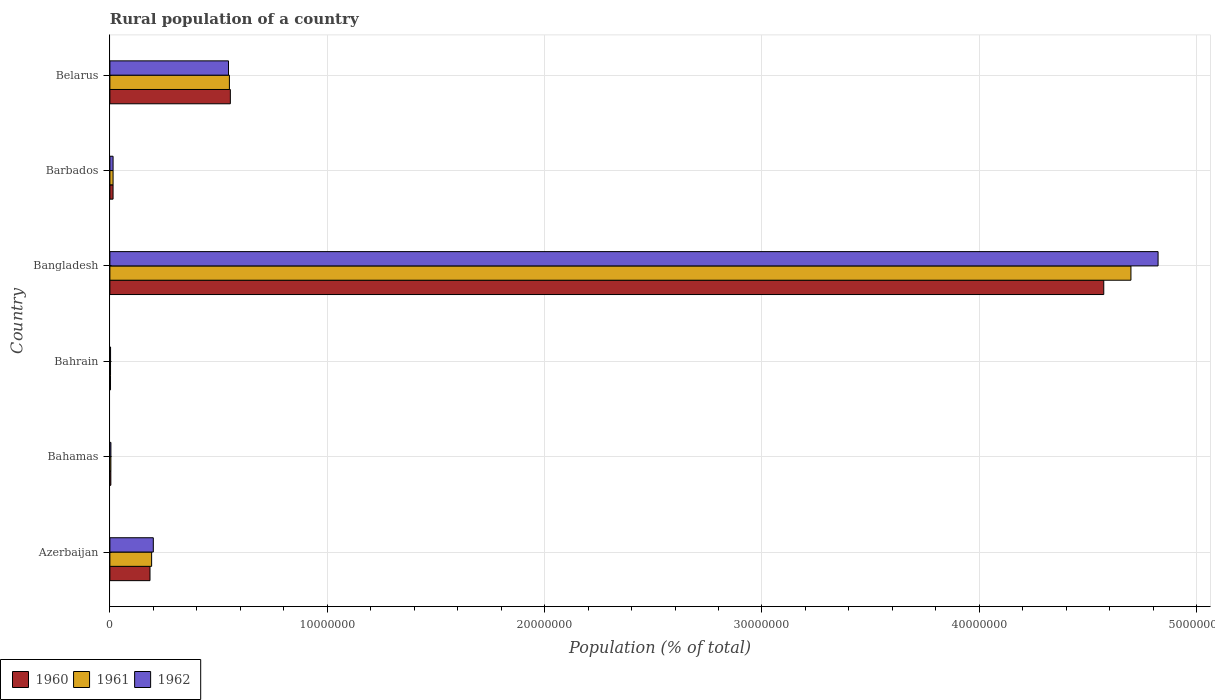How many different coloured bars are there?
Provide a short and direct response. 3. How many bars are there on the 6th tick from the top?
Offer a very short reply. 3. What is the label of the 2nd group of bars from the top?
Your answer should be compact. Barbados. In how many cases, is the number of bars for a given country not equal to the number of legend labels?
Provide a short and direct response. 0. What is the rural population in 1960 in Bangladesh?
Your response must be concise. 4.57e+07. Across all countries, what is the maximum rural population in 1962?
Keep it short and to the point. 4.82e+07. Across all countries, what is the minimum rural population in 1960?
Give a very brief answer. 2.87e+04. In which country was the rural population in 1960 minimum?
Provide a short and direct response. Bahrain. What is the total rural population in 1962 in the graph?
Offer a very short reply. 5.59e+07. What is the difference between the rural population in 1960 in Barbados and that in Belarus?
Ensure brevity in your answer.  -5.40e+06. What is the difference between the rural population in 1962 in Bahamas and the rural population in 1960 in Barbados?
Offer a very short reply. -9.90e+04. What is the average rural population in 1960 per country?
Provide a succinct answer. 8.89e+06. What is the difference between the rural population in 1962 and rural population in 1960 in Bahamas?
Your answer should be compact. 2863. In how many countries, is the rural population in 1962 greater than 14000000 %?
Provide a succinct answer. 1. What is the ratio of the rural population in 1960 in Azerbaijan to that in Bahrain?
Offer a terse response. 64.22. Is the rural population in 1962 in Azerbaijan less than that in Barbados?
Provide a succinct answer. No. Is the difference between the rural population in 1962 in Bahamas and Belarus greater than the difference between the rural population in 1960 in Bahamas and Belarus?
Ensure brevity in your answer.  Yes. What is the difference between the highest and the second highest rural population in 1960?
Your response must be concise. 4.02e+07. What is the difference between the highest and the lowest rural population in 1962?
Offer a very short reply. 4.82e+07. Is the sum of the rural population in 1960 in Bahrain and Bangladesh greater than the maximum rural population in 1962 across all countries?
Your answer should be compact. No. What does the 3rd bar from the bottom in Bangladesh represents?
Your answer should be compact. 1962. How many bars are there?
Make the answer very short. 18. What is the difference between two consecutive major ticks on the X-axis?
Your answer should be very brief. 1.00e+07. Are the values on the major ticks of X-axis written in scientific E-notation?
Provide a succinct answer. No. Does the graph contain grids?
Offer a terse response. Yes. How many legend labels are there?
Your answer should be very brief. 3. What is the title of the graph?
Provide a succinct answer. Rural population of a country. Does "1977" appear as one of the legend labels in the graph?
Your answer should be very brief. No. What is the label or title of the X-axis?
Make the answer very short. Population (% of total). What is the label or title of the Y-axis?
Offer a very short reply. Country. What is the Population (% of total) in 1960 in Azerbaijan?
Offer a terse response. 1.85e+06. What is the Population (% of total) in 1961 in Azerbaijan?
Your response must be concise. 1.92e+06. What is the Population (% of total) in 1962 in Azerbaijan?
Make the answer very short. 2.00e+06. What is the Population (% of total) in 1960 in Bahamas?
Ensure brevity in your answer.  4.41e+04. What is the Population (% of total) of 1961 in Bahamas?
Your answer should be compact. 4.55e+04. What is the Population (% of total) in 1962 in Bahamas?
Provide a short and direct response. 4.70e+04. What is the Population (% of total) of 1960 in Bahrain?
Your response must be concise. 2.87e+04. What is the Population (% of total) in 1961 in Bahrain?
Give a very brief answer. 2.97e+04. What is the Population (% of total) in 1962 in Bahrain?
Offer a terse response. 3.05e+04. What is the Population (% of total) in 1960 in Bangladesh?
Give a very brief answer. 4.57e+07. What is the Population (% of total) in 1961 in Bangladesh?
Provide a short and direct response. 4.70e+07. What is the Population (% of total) of 1962 in Bangladesh?
Give a very brief answer. 4.82e+07. What is the Population (% of total) of 1960 in Barbados?
Give a very brief answer. 1.46e+05. What is the Population (% of total) in 1961 in Barbados?
Keep it short and to the point. 1.46e+05. What is the Population (% of total) of 1962 in Barbados?
Make the answer very short. 1.47e+05. What is the Population (% of total) in 1960 in Belarus?
Your response must be concise. 5.54e+06. What is the Population (% of total) in 1961 in Belarus?
Your answer should be very brief. 5.50e+06. What is the Population (% of total) in 1962 in Belarus?
Make the answer very short. 5.46e+06. Across all countries, what is the maximum Population (% of total) in 1960?
Give a very brief answer. 4.57e+07. Across all countries, what is the maximum Population (% of total) in 1961?
Offer a very short reply. 4.70e+07. Across all countries, what is the maximum Population (% of total) of 1962?
Your answer should be compact. 4.82e+07. Across all countries, what is the minimum Population (% of total) of 1960?
Offer a terse response. 2.87e+04. Across all countries, what is the minimum Population (% of total) of 1961?
Provide a short and direct response. 2.97e+04. Across all countries, what is the minimum Population (% of total) in 1962?
Give a very brief answer. 3.05e+04. What is the total Population (% of total) of 1960 in the graph?
Your answer should be very brief. 5.33e+07. What is the total Population (% of total) of 1961 in the graph?
Your answer should be very brief. 5.46e+07. What is the total Population (% of total) in 1962 in the graph?
Your response must be concise. 5.59e+07. What is the difference between the Population (% of total) of 1960 in Azerbaijan and that in Bahamas?
Make the answer very short. 1.80e+06. What is the difference between the Population (% of total) of 1961 in Azerbaijan and that in Bahamas?
Offer a terse response. 1.87e+06. What is the difference between the Population (% of total) in 1962 in Azerbaijan and that in Bahamas?
Offer a terse response. 1.95e+06. What is the difference between the Population (% of total) of 1960 in Azerbaijan and that in Bahrain?
Your response must be concise. 1.82e+06. What is the difference between the Population (% of total) in 1961 in Azerbaijan and that in Bahrain?
Keep it short and to the point. 1.89e+06. What is the difference between the Population (% of total) of 1962 in Azerbaijan and that in Bahrain?
Ensure brevity in your answer.  1.97e+06. What is the difference between the Population (% of total) in 1960 in Azerbaijan and that in Bangladesh?
Your answer should be very brief. -4.39e+07. What is the difference between the Population (% of total) in 1961 in Azerbaijan and that in Bangladesh?
Offer a very short reply. -4.51e+07. What is the difference between the Population (% of total) of 1962 in Azerbaijan and that in Bangladesh?
Offer a very short reply. -4.62e+07. What is the difference between the Population (% of total) of 1960 in Azerbaijan and that in Barbados?
Your answer should be compact. 1.70e+06. What is the difference between the Population (% of total) in 1961 in Azerbaijan and that in Barbados?
Your response must be concise. 1.77e+06. What is the difference between the Population (% of total) of 1962 in Azerbaijan and that in Barbados?
Your answer should be compact. 1.85e+06. What is the difference between the Population (% of total) in 1960 in Azerbaijan and that in Belarus?
Keep it short and to the point. -3.70e+06. What is the difference between the Population (% of total) in 1961 in Azerbaijan and that in Belarus?
Keep it short and to the point. -3.58e+06. What is the difference between the Population (% of total) of 1962 in Azerbaijan and that in Belarus?
Provide a short and direct response. -3.46e+06. What is the difference between the Population (% of total) of 1960 in Bahamas and that in Bahrain?
Make the answer very short. 1.54e+04. What is the difference between the Population (% of total) in 1961 in Bahamas and that in Bahrain?
Make the answer very short. 1.59e+04. What is the difference between the Population (% of total) of 1962 in Bahamas and that in Bahrain?
Offer a very short reply. 1.64e+04. What is the difference between the Population (% of total) of 1960 in Bahamas and that in Bangladesh?
Ensure brevity in your answer.  -4.57e+07. What is the difference between the Population (% of total) in 1961 in Bahamas and that in Bangladesh?
Keep it short and to the point. -4.69e+07. What is the difference between the Population (% of total) in 1962 in Bahamas and that in Bangladesh?
Ensure brevity in your answer.  -4.82e+07. What is the difference between the Population (% of total) in 1960 in Bahamas and that in Barbados?
Give a very brief answer. -1.02e+05. What is the difference between the Population (% of total) in 1961 in Bahamas and that in Barbados?
Offer a very short reply. -1.01e+05. What is the difference between the Population (% of total) of 1962 in Bahamas and that in Barbados?
Ensure brevity in your answer.  -9.97e+04. What is the difference between the Population (% of total) of 1960 in Bahamas and that in Belarus?
Your response must be concise. -5.50e+06. What is the difference between the Population (% of total) in 1961 in Bahamas and that in Belarus?
Keep it short and to the point. -5.45e+06. What is the difference between the Population (% of total) in 1962 in Bahamas and that in Belarus?
Your answer should be very brief. -5.41e+06. What is the difference between the Population (% of total) in 1960 in Bahrain and that in Bangladesh?
Provide a succinct answer. -4.57e+07. What is the difference between the Population (% of total) of 1961 in Bahrain and that in Bangladesh?
Your response must be concise. -4.69e+07. What is the difference between the Population (% of total) in 1962 in Bahrain and that in Bangladesh?
Provide a succinct answer. -4.82e+07. What is the difference between the Population (% of total) in 1960 in Bahrain and that in Barbados?
Provide a short and direct response. -1.17e+05. What is the difference between the Population (% of total) of 1961 in Bahrain and that in Barbados?
Provide a succinct answer. -1.17e+05. What is the difference between the Population (% of total) of 1962 in Bahrain and that in Barbados?
Your answer should be compact. -1.16e+05. What is the difference between the Population (% of total) of 1960 in Bahrain and that in Belarus?
Keep it short and to the point. -5.51e+06. What is the difference between the Population (% of total) in 1961 in Bahrain and that in Belarus?
Your answer should be compact. -5.47e+06. What is the difference between the Population (% of total) in 1962 in Bahrain and that in Belarus?
Your answer should be very brief. -5.43e+06. What is the difference between the Population (% of total) in 1960 in Bangladesh and that in Barbados?
Give a very brief answer. 4.56e+07. What is the difference between the Population (% of total) in 1961 in Bangladesh and that in Barbados?
Make the answer very short. 4.68e+07. What is the difference between the Population (% of total) in 1962 in Bangladesh and that in Barbados?
Offer a very short reply. 4.81e+07. What is the difference between the Population (% of total) in 1960 in Bangladesh and that in Belarus?
Provide a succinct answer. 4.02e+07. What is the difference between the Population (% of total) in 1961 in Bangladesh and that in Belarus?
Your response must be concise. 4.15e+07. What is the difference between the Population (% of total) in 1962 in Bangladesh and that in Belarus?
Your response must be concise. 4.28e+07. What is the difference between the Population (% of total) in 1960 in Barbados and that in Belarus?
Your response must be concise. -5.40e+06. What is the difference between the Population (% of total) in 1961 in Barbados and that in Belarus?
Keep it short and to the point. -5.35e+06. What is the difference between the Population (% of total) of 1962 in Barbados and that in Belarus?
Keep it short and to the point. -5.31e+06. What is the difference between the Population (% of total) in 1960 in Azerbaijan and the Population (% of total) in 1961 in Bahamas?
Provide a short and direct response. 1.80e+06. What is the difference between the Population (% of total) in 1960 in Azerbaijan and the Population (% of total) in 1962 in Bahamas?
Your response must be concise. 1.80e+06. What is the difference between the Population (% of total) of 1961 in Azerbaijan and the Population (% of total) of 1962 in Bahamas?
Ensure brevity in your answer.  1.87e+06. What is the difference between the Population (% of total) in 1960 in Azerbaijan and the Population (% of total) in 1961 in Bahrain?
Offer a very short reply. 1.82e+06. What is the difference between the Population (% of total) of 1960 in Azerbaijan and the Population (% of total) of 1962 in Bahrain?
Keep it short and to the point. 1.81e+06. What is the difference between the Population (% of total) of 1961 in Azerbaijan and the Population (% of total) of 1962 in Bahrain?
Offer a very short reply. 1.89e+06. What is the difference between the Population (% of total) of 1960 in Azerbaijan and the Population (% of total) of 1961 in Bangladesh?
Your response must be concise. -4.51e+07. What is the difference between the Population (% of total) of 1960 in Azerbaijan and the Population (% of total) of 1962 in Bangladesh?
Your response must be concise. -4.64e+07. What is the difference between the Population (% of total) of 1961 in Azerbaijan and the Population (% of total) of 1962 in Bangladesh?
Your response must be concise. -4.63e+07. What is the difference between the Population (% of total) of 1960 in Azerbaijan and the Population (% of total) of 1961 in Barbados?
Provide a short and direct response. 1.70e+06. What is the difference between the Population (% of total) of 1960 in Azerbaijan and the Population (% of total) of 1962 in Barbados?
Provide a short and direct response. 1.70e+06. What is the difference between the Population (% of total) of 1961 in Azerbaijan and the Population (% of total) of 1962 in Barbados?
Ensure brevity in your answer.  1.77e+06. What is the difference between the Population (% of total) of 1960 in Azerbaijan and the Population (% of total) of 1961 in Belarus?
Your answer should be very brief. -3.65e+06. What is the difference between the Population (% of total) in 1960 in Azerbaijan and the Population (% of total) in 1962 in Belarus?
Your answer should be compact. -3.61e+06. What is the difference between the Population (% of total) of 1961 in Azerbaijan and the Population (% of total) of 1962 in Belarus?
Offer a very short reply. -3.54e+06. What is the difference between the Population (% of total) in 1960 in Bahamas and the Population (% of total) in 1961 in Bahrain?
Make the answer very short. 1.45e+04. What is the difference between the Population (% of total) of 1960 in Bahamas and the Population (% of total) of 1962 in Bahrain?
Provide a succinct answer. 1.36e+04. What is the difference between the Population (% of total) of 1961 in Bahamas and the Population (% of total) of 1962 in Bahrain?
Provide a short and direct response. 1.50e+04. What is the difference between the Population (% of total) of 1960 in Bahamas and the Population (% of total) of 1961 in Bangladesh?
Offer a very short reply. -4.69e+07. What is the difference between the Population (% of total) in 1960 in Bahamas and the Population (% of total) in 1962 in Bangladesh?
Your answer should be very brief. -4.82e+07. What is the difference between the Population (% of total) in 1961 in Bahamas and the Population (% of total) in 1962 in Bangladesh?
Make the answer very short. -4.82e+07. What is the difference between the Population (% of total) of 1960 in Bahamas and the Population (% of total) of 1961 in Barbados?
Provide a short and direct response. -1.02e+05. What is the difference between the Population (% of total) of 1960 in Bahamas and the Population (% of total) of 1962 in Barbados?
Ensure brevity in your answer.  -1.03e+05. What is the difference between the Population (% of total) in 1961 in Bahamas and the Population (% of total) in 1962 in Barbados?
Offer a terse response. -1.01e+05. What is the difference between the Population (% of total) of 1960 in Bahamas and the Population (% of total) of 1961 in Belarus?
Give a very brief answer. -5.45e+06. What is the difference between the Population (% of total) of 1960 in Bahamas and the Population (% of total) of 1962 in Belarus?
Your response must be concise. -5.41e+06. What is the difference between the Population (% of total) in 1961 in Bahamas and the Population (% of total) in 1962 in Belarus?
Ensure brevity in your answer.  -5.41e+06. What is the difference between the Population (% of total) of 1960 in Bahrain and the Population (% of total) of 1961 in Bangladesh?
Give a very brief answer. -4.69e+07. What is the difference between the Population (% of total) of 1960 in Bahrain and the Population (% of total) of 1962 in Bangladesh?
Make the answer very short. -4.82e+07. What is the difference between the Population (% of total) in 1961 in Bahrain and the Population (% of total) in 1962 in Bangladesh?
Ensure brevity in your answer.  -4.82e+07. What is the difference between the Population (% of total) in 1960 in Bahrain and the Population (% of total) in 1961 in Barbados?
Provide a succinct answer. -1.18e+05. What is the difference between the Population (% of total) of 1960 in Bahrain and the Population (% of total) of 1962 in Barbados?
Offer a terse response. -1.18e+05. What is the difference between the Population (% of total) in 1961 in Bahrain and the Population (% of total) in 1962 in Barbados?
Give a very brief answer. -1.17e+05. What is the difference between the Population (% of total) in 1960 in Bahrain and the Population (% of total) in 1961 in Belarus?
Your response must be concise. -5.47e+06. What is the difference between the Population (% of total) of 1960 in Bahrain and the Population (% of total) of 1962 in Belarus?
Offer a very short reply. -5.43e+06. What is the difference between the Population (% of total) in 1961 in Bahrain and the Population (% of total) in 1962 in Belarus?
Your answer should be very brief. -5.43e+06. What is the difference between the Population (% of total) of 1960 in Bangladesh and the Population (% of total) of 1961 in Barbados?
Offer a terse response. 4.56e+07. What is the difference between the Population (% of total) in 1960 in Bangladesh and the Population (% of total) in 1962 in Barbados?
Your answer should be compact. 4.56e+07. What is the difference between the Population (% of total) in 1961 in Bangladesh and the Population (% of total) in 1962 in Barbados?
Make the answer very short. 4.68e+07. What is the difference between the Population (% of total) in 1960 in Bangladesh and the Population (% of total) in 1961 in Belarus?
Give a very brief answer. 4.02e+07. What is the difference between the Population (% of total) in 1960 in Bangladesh and the Population (% of total) in 1962 in Belarus?
Ensure brevity in your answer.  4.03e+07. What is the difference between the Population (% of total) of 1961 in Bangladesh and the Population (% of total) of 1962 in Belarus?
Give a very brief answer. 4.15e+07. What is the difference between the Population (% of total) of 1960 in Barbados and the Population (% of total) of 1961 in Belarus?
Your response must be concise. -5.35e+06. What is the difference between the Population (% of total) in 1960 in Barbados and the Population (% of total) in 1962 in Belarus?
Your response must be concise. -5.31e+06. What is the difference between the Population (% of total) of 1961 in Barbados and the Population (% of total) of 1962 in Belarus?
Your answer should be very brief. -5.31e+06. What is the average Population (% of total) in 1960 per country?
Your answer should be compact. 8.89e+06. What is the average Population (% of total) of 1961 per country?
Provide a succinct answer. 9.10e+06. What is the average Population (% of total) of 1962 per country?
Your response must be concise. 9.32e+06. What is the difference between the Population (% of total) of 1960 and Population (% of total) of 1961 in Azerbaijan?
Offer a very short reply. -7.46e+04. What is the difference between the Population (% of total) of 1960 and Population (% of total) of 1962 in Azerbaijan?
Ensure brevity in your answer.  -1.53e+05. What is the difference between the Population (% of total) in 1961 and Population (% of total) in 1962 in Azerbaijan?
Provide a short and direct response. -7.80e+04. What is the difference between the Population (% of total) of 1960 and Population (% of total) of 1961 in Bahamas?
Your response must be concise. -1395. What is the difference between the Population (% of total) of 1960 and Population (% of total) of 1962 in Bahamas?
Your answer should be very brief. -2863. What is the difference between the Population (% of total) in 1961 and Population (% of total) in 1962 in Bahamas?
Ensure brevity in your answer.  -1468. What is the difference between the Population (% of total) of 1960 and Population (% of total) of 1961 in Bahrain?
Your answer should be very brief. -930. What is the difference between the Population (% of total) in 1960 and Population (% of total) in 1962 in Bahrain?
Offer a very short reply. -1815. What is the difference between the Population (% of total) in 1961 and Population (% of total) in 1962 in Bahrain?
Keep it short and to the point. -885. What is the difference between the Population (% of total) of 1960 and Population (% of total) of 1961 in Bangladesh?
Offer a terse response. -1.25e+06. What is the difference between the Population (% of total) of 1960 and Population (% of total) of 1962 in Bangladesh?
Provide a short and direct response. -2.50e+06. What is the difference between the Population (% of total) in 1961 and Population (% of total) in 1962 in Bangladesh?
Your answer should be very brief. -1.25e+06. What is the difference between the Population (% of total) of 1960 and Population (% of total) of 1961 in Barbados?
Your response must be concise. -301. What is the difference between the Population (% of total) of 1960 and Population (% of total) of 1962 in Barbados?
Make the answer very short. -706. What is the difference between the Population (% of total) of 1961 and Population (% of total) of 1962 in Barbados?
Keep it short and to the point. -405. What is the difference between the Population (% of total) in 1960 and Population (% of total) in 1961 in Belarus?
Your answer should be very brief. 4.32e+04. What is the difference between the Population (% of total) in 1960 and Population (% of total) in 1962 in Belarus?
Ensure brevity in your answer.  8.49e+04. What is the difference between the Population (% of total) in 1961 and Population (% of total) in 1962 in Belarus?
Your answer should be compact. 4.16e+04. What is the ratio of the Population (% of total) of 1960 in Azerbaijan to that in Bahamas?
Your answer should be compact. 41.82. What is the ratio of the Population (% of total) of 1961 in Azerbaijan to that in Bahamas?
Give a very brief answer. 42.17. What is the ratio of the Population (% of total) of 1962 in Azerbaijan to that in Bahamas?
Provide a succinct answer. 42.52. What is the ratio of the Population (% of total) in 1960 in Azerbaijan to that in Bahrain?
Offer a very short reply. 64.22. What is the ratio of the Population (% of total) in 1961 in Azerbaijan to that in Bahrain?
Offer a terse response. 64.73. What is the ratio of the Population (% of total) of 1962 in Azerbaijan to that in Bahrain?
Provide a short and direct response. 65.4. What is the ratio of the Population (% of total) in 1960 in Azerbaijan to that in Bangladesh?
Offer a very short reply. 0.04. What is the ratio of the Population (% of total) of 1961 in Azerbaijan to that in Bangladesh?
Ensure brevity in your answer.  0.04. What is the ratio of the Population (% of total) in 1962 in Azerbaijan to that in Bangladesh?
Ensure brevity in your answer.  0.04. What is the ratio of the Population (% of total) of 1960 in Azerbaijan to that in Barbados?
Ensure brevity in your answer.  12.64. What is the ratio of the Population (% of total) in 1961 in Azerbaijan to that in Barbados?
Offer a terse response. 13.12. What is the ratio of the Population (% of total) in 1962 in Azerbaijan to that in Barbados?
Offer a very short reply. 13.62. What is the ratio of the Population (% of total) in 1960 in Azerbaijan to that in Belarus?
Your answer should be compact. 0.33. What is the ratio of the Population (% of total) in 1961 in Azerbaijan to that in Belarus?
Offer a terse response. 0.35. What is the ratio of the Population (% of total) of 1962 in Azerbaijan to that in Belarus?
Offer a terse response. 0.37. What is the ratio of the Population (% of total) in 1960 in Bahamas to that in Bahrain?
Make the answer very short. 1.54. What is the ratio of the Population (% of total) in 1961 in Bahamas to that in Bahrain?
Offer a terse response. 1.53. What is the ratio of the Population (% of total) of 1962 in Bahamas to that in Bahrain?
Make the answer very short. 1.54. What is the ratio of the Population (% of total) in 1961 in Bahamas to that in Bangladesh?
Offer a very short reply. 0. What is the ratio of the Population (% of total) of 1962 in Bahamas to that in Bangladesh?
Provide a succinct answer. 0. What is the ratio of the Population (% of total) in 1960 in Bahamas to that in Barbados?
Ensure brevity in your answer.  0.3. What is the ratio of the Population (% of total) of 1961 in Bahamas to that in Barbados?
Your answer should be very brief. 0.31. What is the ratio of the Population (% of total) of 1962 in Bahamas to that in Barbados?
Give a very brief answer. 0.32. What is the ratio of the Population (% of total) in 1960 in Bahamas to that in Belarus?
Provide a succinct answer. 0.01. What is the ratio of the Population (% of total) in 1961 in Bahamas to that in Belarus?
Make the answer very short. 0.01. What is the ratio of the Population (% of total) of 1962 in Bahamas to that in Belarus?
Keep it short and to the point. 0.01. What is the ratio of the Population (% of total) in 1960 in Bahrain to that in Bangladesh?
Your answer should be compact. 0. What is the ratio of the Population (% of total) of 1961 in Bahrain to that in Bangladesh?
Provide a succinct answer. 0. What is the ratio of the Population (% of total) of 1962 in Bahrain to that in Bangladesh?
Keep it short and to the point. 0. What is the ratio of the Population (% of total) in 1960 in Bahrain to that in Barbados?
Provide a short and direct response. 0.2. What is the ratio of the Population (% of total) in 1961 in Bahrain to that in Barbados?
Provide a short and direct response. 0.2. What is the ratio of the Population (% of total) of 1962 in Bahrain to that in Barbados?
Your answer should be compact. 0.21. What is the ratio of the Population (% of total) of 1960 in Bahrain to that in Belarus?
Your answer should be very brief. 0.01. What is the ratio of the Population (% of total) of 1961 in Bahrain to that in Belarus?
Ensure brevity in your answer.  0.01. What is the ratio of the Population (% of total) of 1962 in Bahrain to that in Belarus?
Offer a terse response. 0.01. What is the ratio of the Population (% of total) in 1960 in Bangladesh to that in Barbados?
Ensure brevity in your answer.  313.18. What is the ratio of the Population (% of total) in 1961 in Bangladesh to that in Barbados?
Your answer should be very brief. 321.09. What is the ratio of the Population (% of total) in 1962 in Bangladesh to that in Barbados?
Make the answer very short. 328.71. What is the ratio of the Population (% of total) of 1960 in Bangladesh to that in Belarus?
Offer a terse response. 8.25. What is the ratio of the Population (% of total) of 1961 in Bangladesh to that in Belarus?
Offer a very short reply. 8.54. What is the ratio of the Population (% of total) of 1962 in Bangladesh to that in Belarus?
Your response must be concise. 8.84. What is the ratio of the Population (% of total) in 1960 in Barbados to that in Belarus?
Give a very brief answer. 0.03. What is the ratio of the Population (% of total) in 1961 in Barbados to that in Belarus?
Give a very brief answer. 0.03. What is the ratio of the Population (% of total) in 1962 in Barbados to that in Belarus?
Give a very brief answer. 0.03. What is the difference between the highest and the second highest Population (% of total) in 1960?
Make the answer very short. 4.02e+07. What is the difference between the highest and the second highest Population (% of total) of 1961?
Provide a succinct answer. 4.15e+07. What is the difference between the highest and the second highest Population (% of total) of 1962?
Provide a succinct answer. 4.28e+07. What is the difference between the highest and the lowest Population (% of total) in 1960?
Offer a very short reply. 4.57e+07. What is the difference between the highest and the lowest Population (% of total) in 1961?
Keep it short and to the point. 4.69e+07. What is the difference between the highest and the lowest Population (% of total) in 1962?
Offer a terse response. 4.82e+07. 